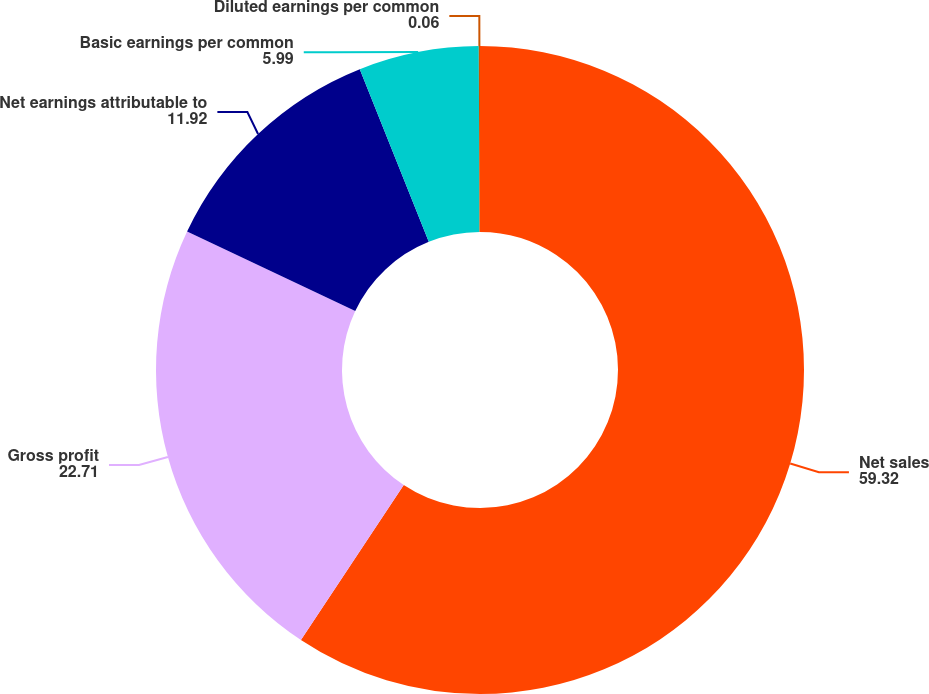Convert chart. <chart><loc_0><loc_0><loc_500><loc_500><pie_chart><fcel>Net sales<fcel>Gross profit<fcel>Net earnings attributable to<fcel>Basic earnings per common<fcel>Diluted earnings per common<nl><fcel>59.32%<fcel>22.71%<fcel>11.92%<fcel>5.99%<fcel>0.06%<nl></chart> 